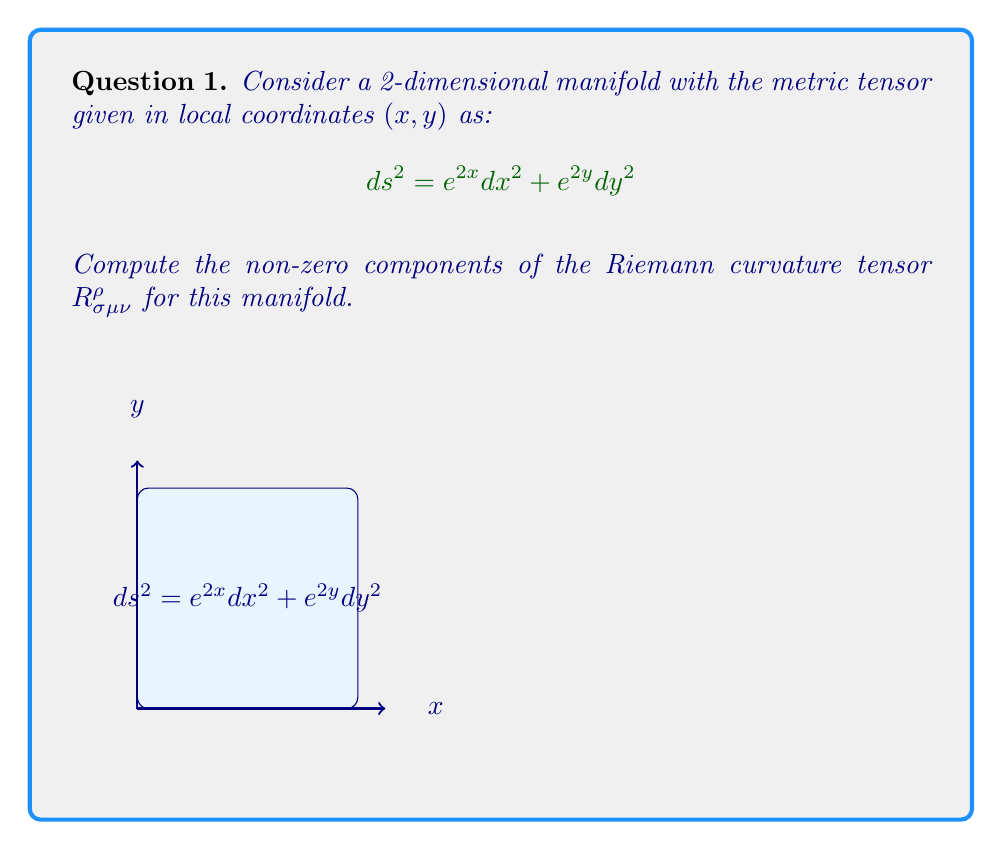Provide a solution to this math problem. To compute the Riemann curvature tensor, we'll follow these steps:

1) First, we need to calculate the Christoffel symbols $\Gamma^{\rho}_{\mu\nu}$. The formula is:

   $$\Gamma^{\rho}_{\mu\nu} = \frac{1}{2}g^{\rho\sigma}(\partial_\mu g_{\nu\sigma} + \partial_\nu g_{\mu\sigma} - \partial_\sigma g_{\mu\nu})$$

2) From the given metric, we can identify:
   
   $g_{11} = e^{2x}$, $g_{22} = e^{2y}$, $g_{12} = g_{21} = 0$

3) The inverse metric is:
   
   $g^{11} = e^{-2x}$, $g^{22} = e^{-2y}$, $g^{12} = g^{21} = 0$

4) Calculating the non-zero Christoffel symbols:

   $\Gamma^1_{11} = \frac{1}{2}g^{11}\partial_1 g_{11} = \frac{1}{2}e^{-2x} \cdot 2e^{2x} = 1$
   
   $\Gamma^2_{22} = \frac{1}{2}g^{22}\partial_2 g_{22} = \frac{1}{2}e^{-2y} \cdot 2e^{2y} = 1$

5) Now, we can compute the Riemann curvature tensor using the formula:

   $$R^{\rho}_{\sigma\mu\nu} = \partial_\mu \Gamma^{\rho}_{\nu\sigma} - \partial_\nu \Gamma^{\rho}_{\mu\sigma} + \Gamma^{\rho}_{\mu\lambda}\Gamma^{\lambda}_{\nu\sigma} - \Gamma^{\rho}_{\nu\lambda}\Gamma^{\lambda}_{\mu\sigma}$$

6) The only non-zero components will be:

   $R^1_{212} = -R^1_{221} = -\partial_2 \Gamma^1_{11} + \Gamma^1_{21}\Gamma^1_{12} - \Gamma^1_{22}\Gamma^2_{11} = 0 - 0 - 0 = 0$
   
   $R^2_{121} = -R^2_{112} = -\partial_1 \Gamma^2_{22} + \Gamma^2_{12}\Gamma^1_{21} - \Gamma^2_{11}\Gamma^1_{22} = 0 - 0 - 0 = 0$

7) All other components are zero due to the symmetries of the Riemann tensor and the fact that many Christoffel symbols are zero for this metric.
Answer: $R^1_{212} = R^1_{221} = R^2_{121} = R^2_{112} = 0$, all other components are zero. 